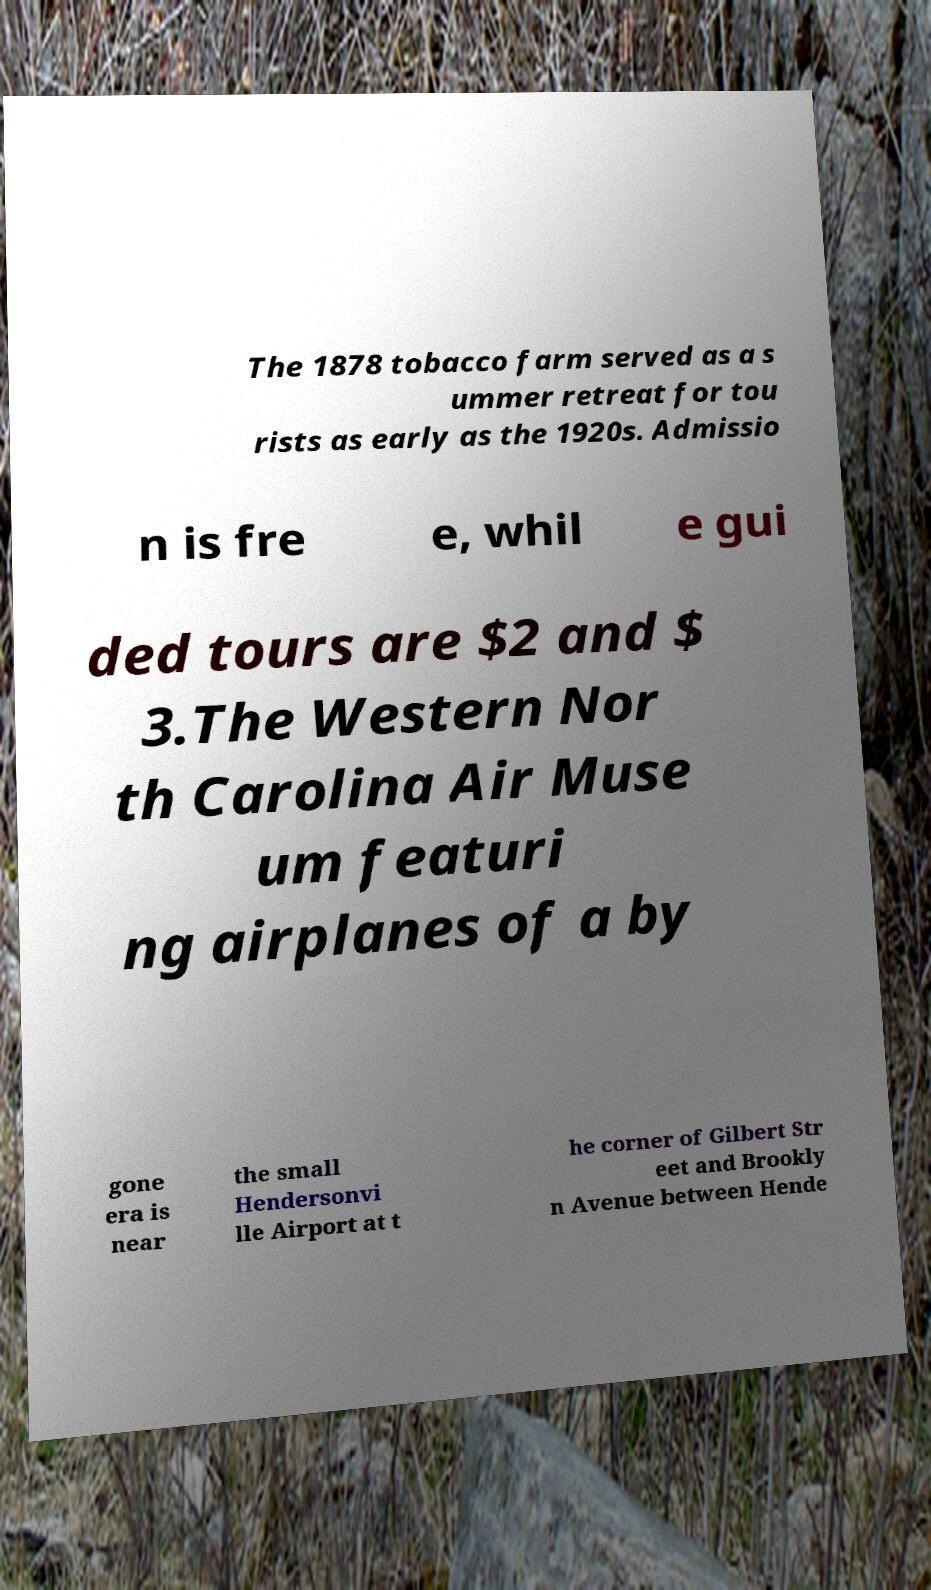Please read and relay the text visible in this image. What does it say? The 1878 tobacco farm served as a s ummer retreat for tou rists as early as the 1920s. Admissio n is fre e, whil e gui ded tours are $2 and $ 3.The Western Nor th Carolina Air Muse um featuri ng airplanes of a by gone era is near the small Hendersonvi lle Airport at t he corner of Gilbert Str eet and Brookly n Avenue between Hende 